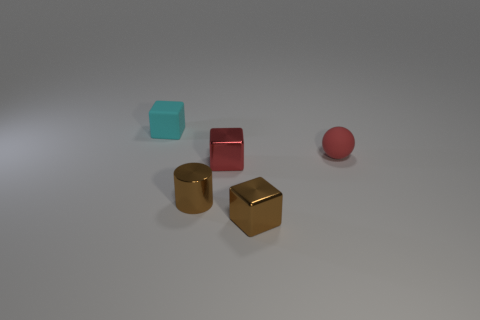There is a cylinder that is the same size as the matte ball; what is it made of?
Keep it short and to the point. Metal. There is a brown object that is the same shape as the small cyan thing; what is it made of?
Your response must be concise. Metal. Do the small cyan rubber object and the tiny red shiny thing have the same shape?
Your answer should be compact. Yes. What number of metallic things are big gray objects or small cyan cubes?
Provide a short and direct response. 0. Does the tiny sphere have the same color as the metal thing that is behind the tiny metallic cylinder?
Provide a short and direct response. Yes. There is a red rubber thing; what shape is it?
Provide a succinct answer. Sphere. What is the size of the cyan rubber cube behind the small matte thing in front of the rubber object that is to the left of the red rubber sphere?
Provide a succinct answer. Small. What number of other objects are the same shape as the small red matte thing?
Your answer should be compact. 0. There is a brown metal thing that is right of the small red shiny block; does it have the same shape as the thing left of the small brown metallic cylinder?
Offer a terse response. Yes. What number of spheres are either small red metallic things or gray metallic things?
Your answer should be very brief. 0. 